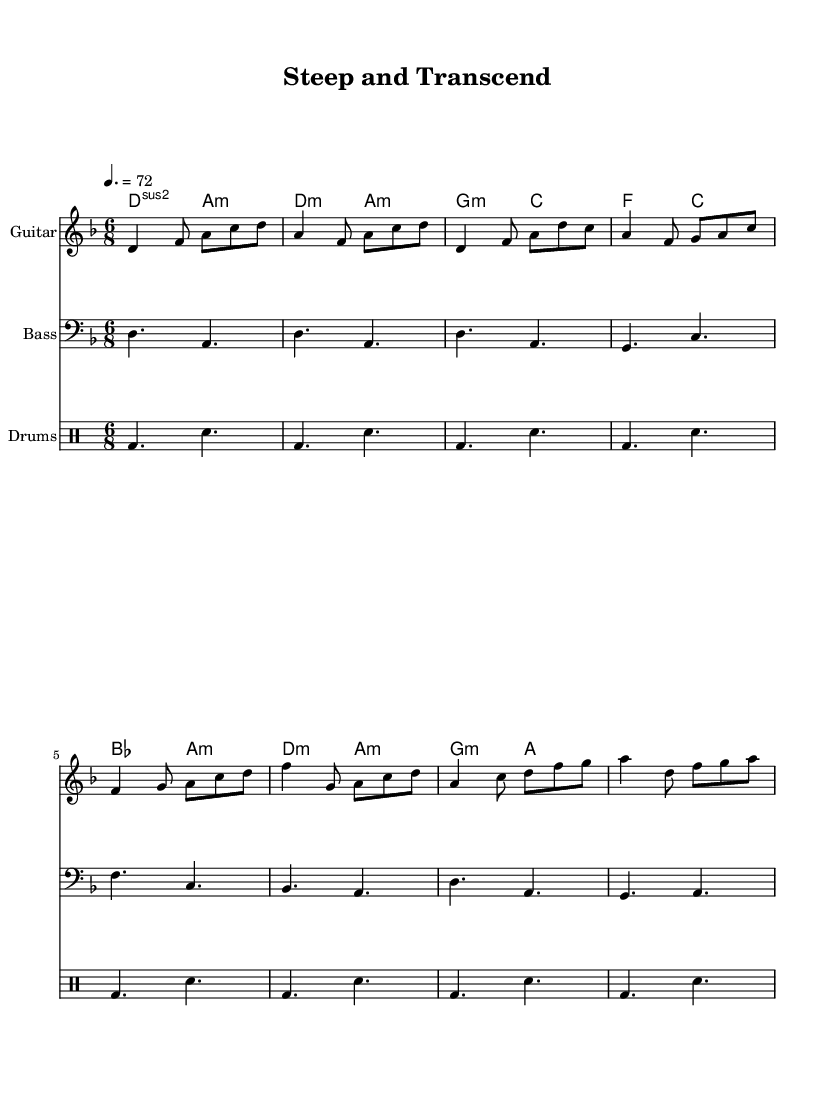What is the key signature of this music? The key signature is indicated at the beginning of the music and shows one flat (B♭).
Answer: D minor What is the time signature of this music? The time signature is located at the beginning of the piece, showing a denominator of 8, indicating eighth note beats in a measure.
Answer: 6/8 What is the tempo marking for this piece? The tempo is indicated in beats per minute just above the staff. It's set to a quarter note equals 72 beats per minute.
Answer: 72 How many measures are in the chorus section? The chorus section is identifiable by the chord changes and rhythmic patterns, and by counting the measures explicitly noted in that section, we see there are 4 measures.
Answer: 4 What chord follows the G minor chord in the verse? By examining the chord progression in the verse, we see the G minor chord is followed by a C major chord.
Answer: C Which instrument plays the main melody? By looking closely, the guitar part, indicated by the instrument name, carries the main melodic line throughout the piece, distinguishing it from the bass and drums.
Answer: Guitar 